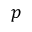Convert formula to latex. <formula><loc_0><loc_0><loc_500><loc_500>p</formula> 